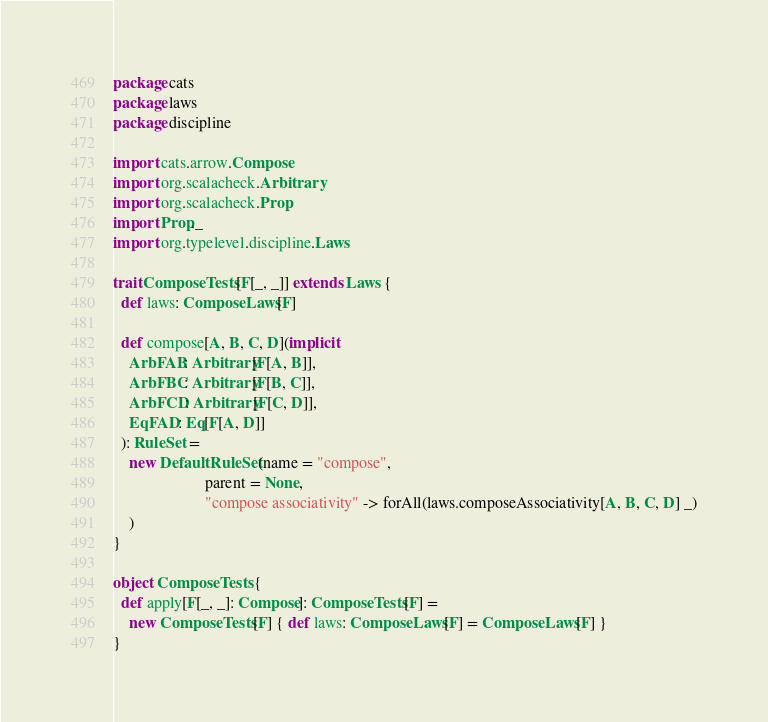<code> <loc_0><loc_0><loc_500><loc_500><_Scala_>package cats
package laws
package discipline

import cats.arrow.Compose
import org.scalacheck.Arbitrary
import org.scalacheck.Prop
import Prop._
import org.typelevel.discipline.Laws

trait ComposeTests[F[_, _]] extends Laws {
  def laws: ComposeLaws[F]

  def compose[A, B, C, D](implicit
    ArbFAB: Arbitrary[F[A, B]],
    ArbFBC: Arbitrary[F[B, C]],
    ArbFCD: Arbitrary[F[C, D]],
    EqFAD: Eq[F[A, D]]
  ): RuleSet =
    new DefaultRuleSet(name = "compose",
                       parent = None,
                       "compose associativity" -> forAll(laws.composeAssociativity[A, B, C, D] _)
    )
}

object ComposeTests {
  def apply[F[_, _]: Compose]: ComposeTests[F] =
    new ComposeTests[F] { def laws: ComposeLaws[F] = ComposeLaws[F] }
}
</code> 